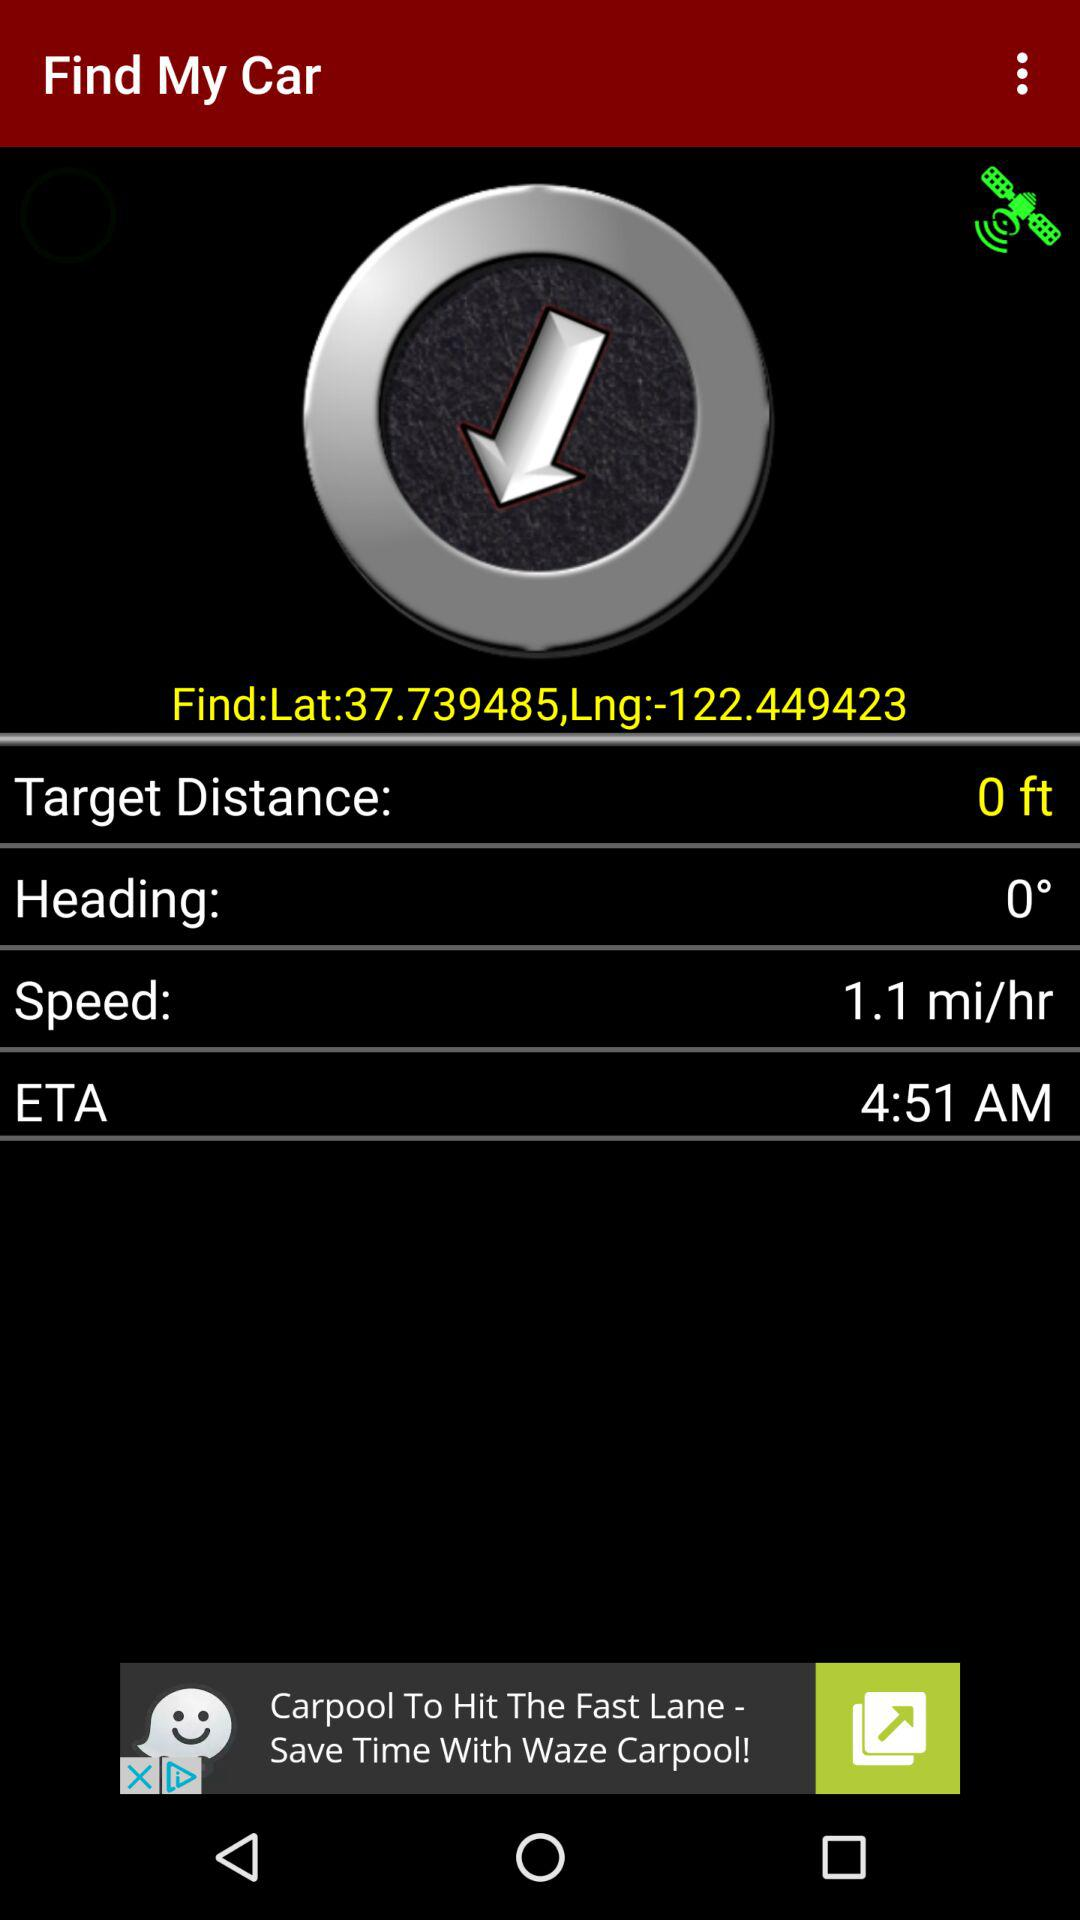What is the speed of the car in miles per hour?
Answer the question using a single word or phrase. 1.1 mi/hr 